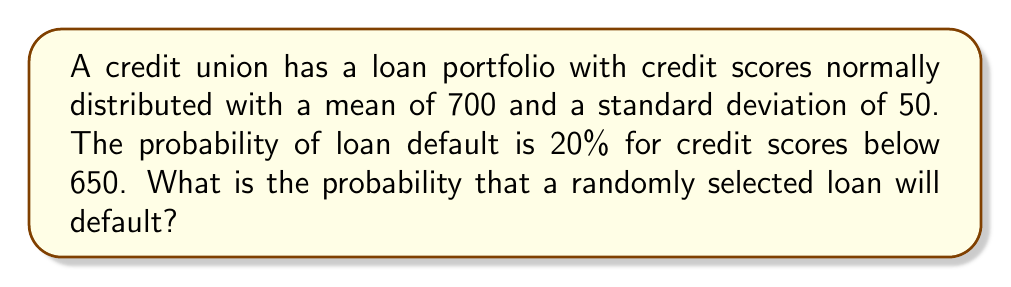Help me with this question. To solve this problem, we need to follow these steps:

1. Standardize the credit score threshold:
   Let $Z$ be the standard normal random variable.
   $$Z = \frac{X - \mu}{\sigma} = \frac{650 - 700}{50} = -1$$

2. Find the probability of a credit score below 650:
   $$P(X < 650) = P(Z < -1) = \Phi(-1)$$
   Where $\Phi$ is the standard normal cumulative distribution function.
   Using a standard normal table or calculator:
   $$\Phi(-1) \approx 0.1587$$

3. Calculate the probability of default:
   The probability of default is 20% for scores below 650, so:
   $$P(\text{Default}) = P(X < 650) \cdot 0.20 = 0.1587 \cdot 0.20 \approx 0.03174$$

Therefore, the probability that a randomly selected loan will default is approximately 0.03174 or 3.174%.
Answer: $0.03174$ or $3.174\%$ 